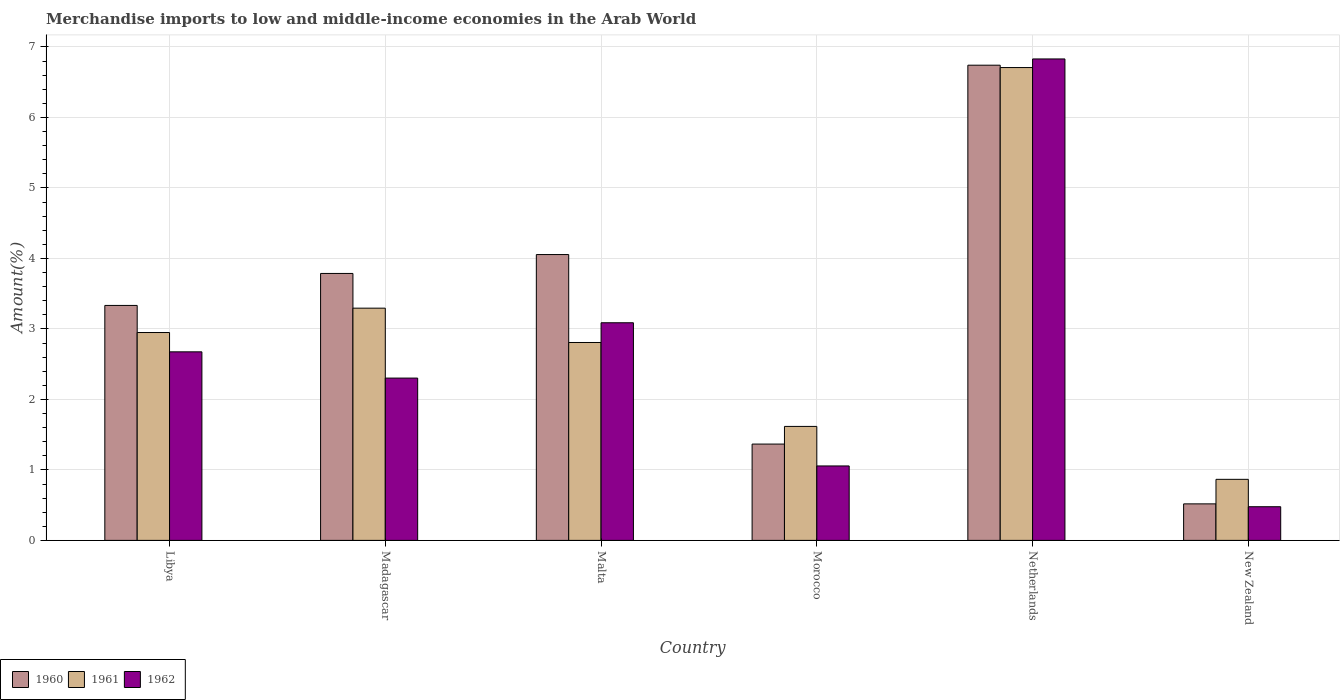How many different coloured bars are there?
Your answer should be compact. 3. How many groups of bars are there?
Your answer should be compact. 6. Are the number of bars per tick equal to the number of legend labels?
Provide a short and direct response. Yes. How many bars are there on the 4th tick from the left?
Ensure brevity in your answer.  3. What is the percentage of amount earned from merchandise imports in 1962 in Morocco?
Offer a terse response. 1.06. Across all countries, what is the maximum percentage of amount earned from merchandise imports in 1960?
Give a very brief answer. 6.74. Across all countries, what is the minimum percentage of amount earned from merchandise imports in 1960?
Offer a terse response. 0.52. In which country was the percentage of amount earned from merchandise imports in 1962 minimum?
Offer a very short reply. New Zealand. What is the total percentage of amount earned from merchandise imports in 1960 in the graph?
Offer a terse response. 19.8. What is the difference between the percentage of amount earned from merchandise imports in 1960 in Malta and that in New Zealand?
Give a very brief answer. 3.54. What is the difference between the percentage of amount earned from merchandise imports in 1962 in New Zealand and the percentage of amount earned from merchandise imports in 1960 in Madagascar?
Ensure brevity in your answer.  -3.31. What is the average percentage of amount earned from merchandise imports in 1962 per country?
Make the answer very short. 2.74. What is the difference between the percentage of amount earned from merchandise imports of/in 1960 and percentage of amount earned from merchandise imports of/in 1961 in New Zealand?
Provide a short and direct response. -0.35. In how many countries, is the percentage of amount earned from merchandise imports in 1961 greater than 3.8 %?
Your response must be concise. 1. What is the ratio of the percentage of amount earned from merchandise imports in 1960 in Madagascar to that in Morocco?
Your response must be concise. 2.77. What is the difference between the highest and the second highest percentage of amount earned from merchandise imports in 1962?
Keep it short and to the point. -0.41. What is the difference between the highest and the lowest percentage of amount earned from merchandise imports in 1961?
Make the answer very short. 5.84. In how many countries, is the percentage of amount earned from merchandise imports in 1962 greater than the average percentage of amount earned from merchandise imports in 1962 taken over all countries?
Give a very brief answer. 2. What does the 3rd bar from the right in Malta represents?
Give a very brief answer. 1960. Are all the bars in the graph horizontal?
Your answer should be compact. No. What is the difference between two consecutive major ticks on the Y-axis?
Provide a short and direct response. 1. Does the graph contain grids?
Your response must be concise. Yes. How are the legend labels stacked?
Offer a very short reply. Horizontal. What is the title of the graph?
Provide a succinct answer. Merchandise imports to low and middle-income economies in the Arab World. What is the label or title of the Y-axis?
Provide a succinct answer. Amount(%). What is the Amount(%) of 1960 in Libya?
Your answer should be compact. 3.33. What is the Amount(%) in 1961 in Libya?
Provide a succinct answer. 2.95. What is the Amount(%) of 1962 in Libya?
Offer a terse response. 2.68. What is the Amount(%) of 1960 in Madagascar?
Your answer should be very brief. 3.79. What is the Amount(%) in 1961 in Madagascar?
Offer a terse response. 3.29. What is the Amount(%) in 1962 in Madagascar?
Your response must be concise. 2.3. What is the Amount(%) in 1960 in Malta?
Ensure brevity in your answer.  4.06. What is the Amount(%) in 1961 in Malta?
Your answer should be compact. 2.81. What is the Amount(%) of 1962 in Malta?
Your answer should be very brief. 3.09. What is the Amount(%) in 1960 in Morocco?
Make the answer very short. 1.37. What is the Amount(%) of 1961 in Morocco?
Offer a terse response. 1.62. What is the Amount(%) in 1962 in Morocco?
Offer a terse response. 1.06. What is the Amount(%) in 1960 in Netherlands?
Keep it short and to the point. 6.74. What is the Amount(%) of 1961 in Netherlands?
Ensure brevity in your answer.  6.71. What is the Amount(%) of 1962 in Netherlands?
Make the answer very short. 6.83. What is the Amount(%) of 1960 in New Zealand?
Give a very brief answer. 0.52. What is the Amount(%) in 1961 in New Zealand?
Ensure brevity in your answer.  0.87. What is the Amount(%) in 1962 in New Zealand?
Make the answer very short. 0.48. Across all countries, what is the maximum Amount(%) of 1960?
Provide a short and direct response. 6.74. Across all countries, what is the maximum Amount(%) in 1961?
Give a very brief answer. 6.71. Across all countries, what is the maximum Amount(%) in 1962?
Your answer should be very brief. 6.83. Across all countries, what is the minimum Amount(%) in 1960?
Provide a succinct answer. 0.52. Across all countries, what is the minimum Amount(%) in 1961?
Your response must be concise. 0.87. Across all countries, what is the minimum Amount(%) in 1962?
Give a very brief answer. 0.48. What is the total Amount(%) in 1960 in the graph?
Provide a succinct answer. 19.8. What is the total Amount(%) of 1961 in the graph?
Offer a very short reply. 18.24. What is the total Amount(%) of 1962 in the graph?
Offer a terse response. 16.43. What is the difference between the Amount(%) of 1960 in Libya and that in Madagascar?
Offer a terse response. -0.45. What is the difference between the Amount(%) in 1961 in Libya and that in Madagascar?
Your answer should be compact. -0.35. What is the difference between the Amount(%) in 1962 in Libya and that in Madagascar?
Offer a terse response. 0.37. What is the difference between the Amount(%) in 1960 in Libya and that in Malta?
Offer a very short reply. -0.72. What is the difference between the Amount(%) of 1961 in Libya and that in Malta?
Keep it short and to the point. 0.14. What is the difference between the Amount(%) in 1962 in Libya and that in Malta?
Your answer should be very brief. -0.41. What is the difference between the Amount(%) in 1960 in Libya and that in Morocco?
Your answer should be compact. 1.97. What is the difference between the Amount(%) of 1961 in Libya and that in Morocco?
Make the answer very short. 1.33. What is the difference between the Amount(%) of 1962 in Libya and that in Morocco?
Provide a succinct answer. 1.62. What is the difference between the Amount(%) in 1960 in Libya and that in Netherlands?
Your response must be concise. -3.41. What is the difference between the Amount(%) in 1961 in Libya and that in Netherlands?
Your answer should be very brief. -3.76. What is the difference between the Amount(%) of 1962 in Libya and that in Netherlands?
Your answer should be compact. -4.16. What is the difference between the Amount(%) of 1960 in Libya and that in New Zealand?
Provide a short and direct response. 2.82. What is the difference between the Amount(%) in 1961 in Libya and that in New Zealand?
Your response must be concise. 2.08. What is the difference between the Amount(%) in 1962 in Libya and that in New Zealand?
Offer a very short reply. 2.2. What is the difference between the Amount(%) in 1960 in Madagascar and that in Malta?
Give a very brief answer. -0.27. What is the difference between the Amount(%) of 1961 in Madagascar and that in Malta?
Keep it short and to the point. 0.49. What is the difference between the Amount(%) of 1962 in Madagascar and that in Malta?
Offer a terse response. -0.79. What is the difference between the Amount(%) of 1960 in Madagascar and that in Morocco?
Provide a succinct answer. 2.42. What is the difference between the Amount(%) of 1961 in Madagascar and that in Morocco?
Provide a succinct answer. 1.68. What is the difference between the Amount(%) of 1962 in Madagascar and that in Morocco?
Your answer should be compact. 1.25. What is the difference between the Amount(%) of 1960 in Madagascar and that in Netherlands?
Your answer should be very brief. -2.95. What is the difference between the Amount(%) in 1961 in Madagascar and that in Netherlands?
Give a very brief answer. -3.41. What is the difference between the Amount(%) in 1962 in Madagascar and that in Netherlands?
Offer a terse response. -4.53. What is the difference between the Amount(%) of 1960 in Madagascar and that in New Zealand?
Ensure brevity in your answer.  3.27. What is the difference between the Amount(%) of 1961 in Madagascar and that in New Zealand?
Your answer should be very brief. 2.43. What is the difference between the Amount(%) in 1962 in Madagascar and that in New Zealand?
Provide a short and direct response. 1.83. What is the difference between the Amount(%) of 1960 in Malta and that in Morocco?
Offer a terse response. 2.69. What is the difference between the Amount(%) in 1961 in Malta and that in Morocco?
Make the answer very short. 1.19. What is the difference between the Amount(%) of 1962 in Malta and that in Morocco?
Your answer should be very brief. 2.03. What is the difference between the Amount(%) of 1960 in Malta and that in Netherlands?
Offer a terse response. -2.69. What is the difference between the Amount(%) of 1961 in Malta and that in Netherlands?
Your response must be concise. -3.9. What is the difference between the Amount(%) of 1962 in Malta and that in Netherlands?
Make the answer very short. -3.74. What is the difference between the Amount(%) in 1960 in Malta and that in New Zealand?
Ensure brevity in your answer.  3.54. What is the difference between the Amount(%) in 1961 in Malta and that in New Zealand?
Your answer should be compact. 1.94. What is the difference between the Amount(%) in 1962 in Malta and that in New Zealand?
Your response must be concise. 2.61. What is the difference between the Amount(%) in 1960 in Morocco and that in Netherlands?
Ensure brevity in your answer.  -5.38. What is the difference between the Amount(%) in 1961 in Morocco and that in Netherlands?
Provide a succinct answer. -5.09. What is the difference between the Amount(%) in 1962 in Morocco and that in Netherlands?
Offer a very short reply. -5.77. What is the difference between the Amount(%) of 1960 in Morocco and that in New Zealand?
Keep it short and to the point. 0.85. What is the difference between the Amount(%) in 1961 in Morocco and that in New Zealand?
Ensure brevity in your answer.  0.75. What is the difference between the Amount(%) in 1962 in Morocco and that in New Zealand?
Your answer should be very brief. 0.58. What is the difference between the Amount(%) of 1960 in Netherlands and that in New Zealand?
Provide a succinct answer. 6.22. What is the difference between the Amount(%) in 1961 in Netherlands and that in New Zealand?
Your answer should be very brief. 5.84. What is the difference between the Amount(%) of 1962 in Netherlands and that in New Zealand?
Make the answer very short. 6.35. What is the difference between the Amount(%) of 1960 in Libya and the Amount(%) of 1961 in Madagascar?
Keep it short and to the point. 0.04. What is the difference between the Amount(%) of 1960 in Libya and the Amount(%) of 1962 in Madagascar?
Make the answer very short. 1.03. What is the difference between the Amount(%) of 1961 in Libya and the Amount(%) of 1962 in Madagascar?
Keep it short and to the point. 0.65. What is the difference between the Amount(%) in 1960 in Libya and the Amount(%) in 1961 in Malta?
Provide a succinct answer. 0.53. What is the difference between the Amount(%) of 1960 in Libya and the Amount(%) of 1962 in Malta?
Provide a short and direct response. 0.25. What is the difference between the Amount(%) in 1961 in Libya and the Amount(%) in 1962 in Malta?
Keep it short and to the point. -0.14. What is the difference between the Amount(%) in 1960 in Libya and the Amount(%) in 1961 in Morocco?
Your response must be concise. 1.72. What is the difference between the Amount(%) in 1960 in Libya and the Amount(%) in 1962 in Morocco?
Offer a very short reply. 2.28. What is the difference between the Amount(%) of 1961 in Libya and the Amount(%) of 1962 in Morocco?
Offer a very short reply. 1.89. What is the difference between the Amount(%) of 1960 in Libya and the Amount(%) of 1961 in Netherlands?
Offer a terse response. -3.37. What is the difference between the Amount(%) in 1960 in Libya and the Amount(%) in 1962 in Netherlands?
Your answer should be compact. -3.5. What is the difference between the Amount(%) in 1961 in Libya and the Amount(%) in 1962 in Netherlands?
Your response must be concise. -3.88. What is the difference between the Amount(%) in 1960 in Libya and the Amount(%) in 1961 in New Zealand?
Offer a very short reply. 2.47. What is the difference between the Amount(%) of 1960 in Libya and the Amount(%) of 1962 in New Zealand?
Make the answer very short. 2.86. What is the difference between the Amount(%) in 1961 in Libya and the Amount(%) in 1962 in New Zealand?
Your answer should be compact. 2.47. What is the difference between the Amount(%) in 1960 in Madagascar and the Amount(%) in 1961 in Malta?
Your answer should be very brief. 0.98. What is the difference between the Amount(%) in 1960 in Madagascar and the Amount(%) in 1962 in Malta?
Give a very brief answer. 0.7. What is the difference between the Amount(%) in 1961 in Madagascar and the Amount(%) in 1962 in Malta?
Ensure brevity in your answer.  0.21. What is the difference between the Amount(%) of 1960 in Madagascar and the Amount(%) of 1961 in Morocco?
Make the answer very short. 2.17. What is the difference between the Amount(%) in 1960 in Madagascar and the Amount(%) in 1962 in Morocco?
Give a very brief answer. 2.73. What is the difference between the Amount(%) of 1961 in Madagascar and the Amount(%) of 1962 in Morocco?
Provide a succinct answer. 2.24. What is the difference between the Amount(%) in 1960 in Madagascar and the Amount(%) in 1961 in Netherlands?
Your answer should be very brief. -2.92. What is the difference between the Amount(%) in 1960 in Madagascar and the Amount(%) in 1962 in Netherlands?
Provide a succinct answer. -3.04. What is the difference between the Amount(%) in 1961 in Madagascar and the Amount(%) in 1962 in Netherlands?
Offer a terse response. -3.54. What is the difference between the Amount(%) in 1960 in Madagascar and the Amount(%) in 1961 in New Zealand?
Make the answer very short. 2.92. What is the difference between the Amount(%) in 1960 in Madagascar and the Amount(%) in 1962 in New Zealand?
Provide a succinct answer. 3.31. What is the difference between the Amount(%) in 1961 in Madagascar and the Amount(%) in 1962 in New Zealand?
Give a very brief answer. 2.82. What is the difference between the Amount(%) of 1960 in Malta and the Amount(%) of 1961 in Morocco?
Your answer should be very brief. 2.44. What is the difference between the Amount(%) of 1960 in Malta and the Amount(%) of 1962 in Morocco?
Ensure brevity in your answer.  3. What is the difference between the Amount(%) of 1961 in Malta and the Amount(%) of 1962 in Morocco?
Provide a succinct answer. 1.75. What is the difference between the Amount(%) of 1960 in Malta and the Amount(%) of 1961 in Netherlands?
Offer a very short reply. -2.65. What is the difference between the Amount(%) in 1960 in Malta and the Amount(%) in 1962 in Netherlands?
Your answer should be compact. -2.77. What is the difference between the Amount(%) of 1961 in Malta and the Amount(%) of 1962 in Netherlands?
Offer a terse response. -4.02. What is the difference between the Amount(%) in 1960 in Malta and the Amount(%) in 1961 in New Zealand?
Your answer should be very brief. 3.19. What is the difference between the Amount(%) in 1960 in Malta and the Amount(%) in 1962 in New Zealand?
Provide a succinct answer. 3.58. What is the difference between the Amount(%) of 1961 in Malta and the Amount(%) of 1962 in New Zealand?
Keep it short and to the point. 2.33. What is the difference between the Amount(%) of 1960 in Morocco and the Amount(%) of 1961 in Netherlands?
Offer a very short reply. -5.34. What is the difference between the Amount(%) in 1960 in Morocco and the Amount(%) in 1962 in Netherlands?
Keep it short and to the point. -5.46. What is the difference between the Amount(%) in 1961 in Morocco and the Amount(%) in 1962 in Netherlands?
Provide a succinct answer. -5.21. What is the difference between the Amount(%) in 1960 in Morocco and the Amount(%) in 1961 in New Zealand?
Ensure brevity in your answer.  0.5. What is the difference between the Amount(%) of 1960 in Morocco and the Amount(%) of 1962 in New Zealand?
Provide a short and direct response. 0.89. What is the difference between the Amount(%) of 1961 in Morocco and the Amount(%) of 1962 in New Zealand?
Your response must be concise. 1.14. What is the difference between the Amount(%) in 1960 in Netherlands and the Amount(%) in 1961 in New Zealand?
Provide a succinct answer. 5.88. What is the difference between the Amount(%) of 1960 in Netherlands and the Amount(%) of 1962 in New Zealand?
Provide a short and direct response. 6.26. What is the difference between the Amount(%) of 1961 in Netherlands and the Amount(%) of 1962 in New Zealand?
Your answer should be very brief. 6.23. What is the average Amount(%) of 1960 per country?
Your answer should be very brief. 3.3. What is the average Amount(%) of 1961 per country?
Keep it short and to the point. 3.04. What is the average Amount(%) of 1962 per country?
Give a very brief answer. 2.74. What is the difference between the Amount(%) of 1960 and Amount(%) of 1961 in Libya?
Provide a succinct answer. 0.38. What is the difference between the Amount(%) of 1960 and Amount(%) of 1962 in Libya?
Give a very brief answer. 0.66. What is the difference between the Amount(%) in 1961 and Amount(%) in 1962 in Libya?
Give a very brief answer. 0.27. What is the difference between the Amount(%) of 1960 and Amount(%) of 1961 in Madagascar?
Give a very brief answer. 0.49. What is the difference between the Amount(%) of 1960 and Amount(%) of 1962 in Madagascar?
Offer a very short reply. 1.48. What is the difference between the Amount(%) of 1961 and Amount(%) of 1962 in Madagascar?
Keep it short and to the point. 0.99. What is the difference between the Amount(%) in 1960 and Amount(%) in 1961 in Malta?
Make the answer very short. 1.25. What is the difference between the Amount(%) of 1960 and Amount(%) of 1962 in Malta?
Keep it short and to the point. 0.97. What is the difference between the Amount(%) of 1961 and Amount(%) of 1962 in Malta?
Your answer should be very brief. -0.28. What is the difference between the Amount(%) in 1960 and Amount(%) in 1961 in Morocco?
Offer a terse response. -0.25. What is the difference between the Amount(%) in 1960 and Amount(%) in 1962 in Morocco?
Provide a succinct answer. 0.31. What is the difference between the Amount(%) in 1961 and Amount(%) in 1962 in Morocco?
Offer a terse response. 0.56. What is the difference between the Amount(%) in 1960 and Amount(%) in 1961 in Netherlands?
Provide a succinct answer. 0.03. What is the difference between the Amount(%) of 1960 and Amount(%) of 1962 in Netherlands?
Offer a very short reply. -0.09. What is the difference between the Amount(%) in 1961 and Amount(%) in 1962 in Netherlands?
Ensure brevity in your answer.  -0.12. What is the difference between the Amount(%) of 1960 and Amount(%) of 1961 in New Zealand?
Your answer should be compact. -0.35. What is the difference between the Amount(%) of 1960 and Amount(%) of 1962 in New Zealand?
Your answer should be compact. 0.04. What is the difference between the Amount(%) of 1961 and Amount(%) of 1962 in New Zealand?
Your response must be concise. 0.39. What is the ratio of the Amount(%) of 1960 in Libya to that in Madagascar?
Ensure brevity in your answer.  0.88. What is the ratio of the Amount(%) of 1961 in Libya to that in Madagascar?
Your response must be concise. 0.9. What is the ratio of the Amount(%) of 1962 in Libya to that in Madagascar?
Keep it short and to the point. 1.16. What is the ratio of the Amount(%) in 1960 in Libya to that in Malta?
Your answer should be compact. 0.82. What is the ratio of the Amount(%) of 1961 in Libya to that in Malta?
Keep it short and to the point. 1.05. What is the ratio of the Amount(%) of 1962 in Libya to that in Malta?
Give a very brief answer. 0.87. What is the ratio of the Amount(%) in 1960 in Libya to that in Morocco?
Give a very brief answer. 2.44. What is the ratio of the Amount(%) in 1961 in Libya to that in Morocco?
Your answer should be very brief. 1.82. What is the ratio of the Amount(%) in 1962 in Libya to that in Morocco?
Provide a succinct answer. 2.53. What is the ratio of the Amount(%) in 1960 in Libya to that in Netherlands?
Your answer should be very brief. 0.49. What is the ratio of the Amount(%) of 1961 in Libya to that in Netherlands?
Your response must be concise. 0.44. What is the ratio of the Amount(%) in 1962 in Libya to that in Netherlands?
Provide a succinct answer. 0.39. What is the ratio of the Amount(%) of 1960 in Libya to that in New Zealand?
Ensure brevity in your answer.  6.43. What is the ratio of the Amount(%) in 1961 in Libya to that in New Zealand?
Your response must be concise. 3.41. What is the ratio of the Amount(%) in 1962 in Libya to that in New Zealand?
Make the answer very short. 5.6. What is the ratio of the Amount(%) of 1960 in Madagascar to that in Malta?
Make the answer very short. 0.93. What is the ratio of the Amount(%) in 1961 in Madagascar to that in Malta?
Provide a succinct answer. 1.17. What is the ratio of the Amount(%) in 1962 in Madagascar to that in Malta?
Make the answer very short. 0.75. What is the ratio of the Amount(%) in 1960 in Madagascar to that in Morocco?
Your answer should be compact. 2.77. What is the ratio of the Amount(%) in 1961 in Madagascar to that in Morocco?
Your response must be concise. 2.04. What is the ratio of the Amount(%) in 1962 in Madagascar to that in Morocco?
Give a very brief answer. 2.18. What is the ratio of the Amount(%) of 1960 in Madagascar to that in Netherlands?
Keep it short and to the point. 0.56. What is the ratio of the Amount(%) in 1961 in Madagascar to that in Netherlands?
Give a very brief answer. 0.49. What is the ratio of the Amount(%) of 1962 in Madagascar to that in Netherlands?
Provide a short and direct response. 0.34. What is the ratio of the Amount(%) of 1960 in Madagascar to that in New Zealand?
Your answer should be very brief. 7.31. What is the ratio of the Amount(%) of 1961 in Madagascar to that in New Zealand?
Make the answer very short. 3.8. What is the ratio of the Amount(%) of 1962 in Madagascar to that in New Zealand?
Offer a terse response. 4.82. What is the ratio of the Amount(%) of 1960 in Malta to that in Morocco?
Keep it short and to the point. 2.97. What is the ratio of the Amount(%) of 1961 in Malta to that in Morocco?
Your answer should be very brief. 1.74. What is the ratio of the Amount(%) of 1962 in Malta to that in Morocco?
Offer a very short reply. 2.92. What is the ratio of the Amount(%) in 1960 in Malta to that in Netherlands?
Your response must be concise. 0.6. What is the ratio of the Amount(%) in 1961 in Malta to that in Netherlands?
Offer a terse response. 0.42. What is the ratio of the Amount(%) in 1962 in Malta to that in Netherlands?
Give a very brief answer. 0.45. What is the ratio of the Amount(%) in 1960 in Malta to that in New Zealand?
Offer a terse response. 7.83. What is the ratio of the Amount(%) of 1961 in Malta to that in New Zealand?
Your response must be concise. 3.24. What is the ratio of the Amount(%) of 1962 in Malta to that in New Zealand?
Ensure brevity in your answer.  6.47. What is the ratio of the Amount(%) of 1960 in Morocco to that in Netherlands?
Give a very brief answer. 0.2. What is the ratio of the Amount(%) in 1961 in Morocco to that in Netherlands?
Your answer should be very brief. 0.24. What is the ratio of the Amount(%) of 1962 in Morocco to that in Netherlands?
Offer a terse response. 0.15. What is the ratio of the Amount(%) in 1960 in Morocco to that in New Zealand?
Your answer should be very brief. 2.64. What is the ratio of the Amount(%) of 1961 in Morocco to that in New Zealand?
Give a very brief answer. 1.87. What is the ratio of the Amount(%) of 1962 in Morocco to that in New Zealand?
Keep it short and to the point. 2.21. What is the ratio of the Amount(%) of 1960 in Netherlands to that in New Zealand?
Provide a succinct answer. 13.01. What is the ratio of the Amount(%) of 1961 in Netherlands to that in New Zealand?
Make the answer very short. 7.75. What is the ratio of the Amount(%) of 1962 in Netherlands to that in New Zealand?
Your answer should be compact. 14.3. What is the difference between the highest and the second highest Amount(%) of 1960?
Ensure brevity in your answer.  2.69. What is the difference between the highest and the second highest Amount(%) in 1961?
Ensure brevity in your answer.  3.41. What is the difference between the highest and the second highest Amount(%) in 1962?
Your answer should be very brief. 3.74. What is the difference between the highest and the lowest Amount(%) of 1960?
Make the answer very short. 6.22. What is the difference between the highest and the lowest Amount(%) of 1961?
Give a very brief answer. 5.84. What is the difference between the highest and the lowest Amount(%) of 1962?
Make the answer very short. 6.35. 